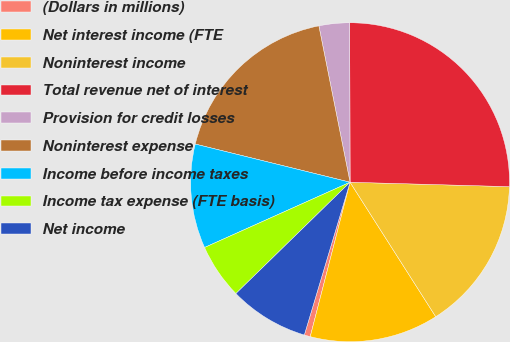<chart> <loc_0><loc_0><loc_500><loc_500><pie_chart><fcel>(Dollars in millions)<fcel>Net interest income (FTE<fcel>Noninterest income<fcel>Total revenue net of interest<fcel>Provision for credit losses<fcel>Noninterest expense<fcel>Income before income taxes<fcel>Income tax expense (FTE basis)<fcel>Net income<nl><fcel>0.61%<fcel>13.05%<fcel>15.53%<fcel>25.48%<fcel>3.1%<fcel>18.02%<fcel>10.56%<fcel>5.59%<fcel>8.07%<nl></chart> 